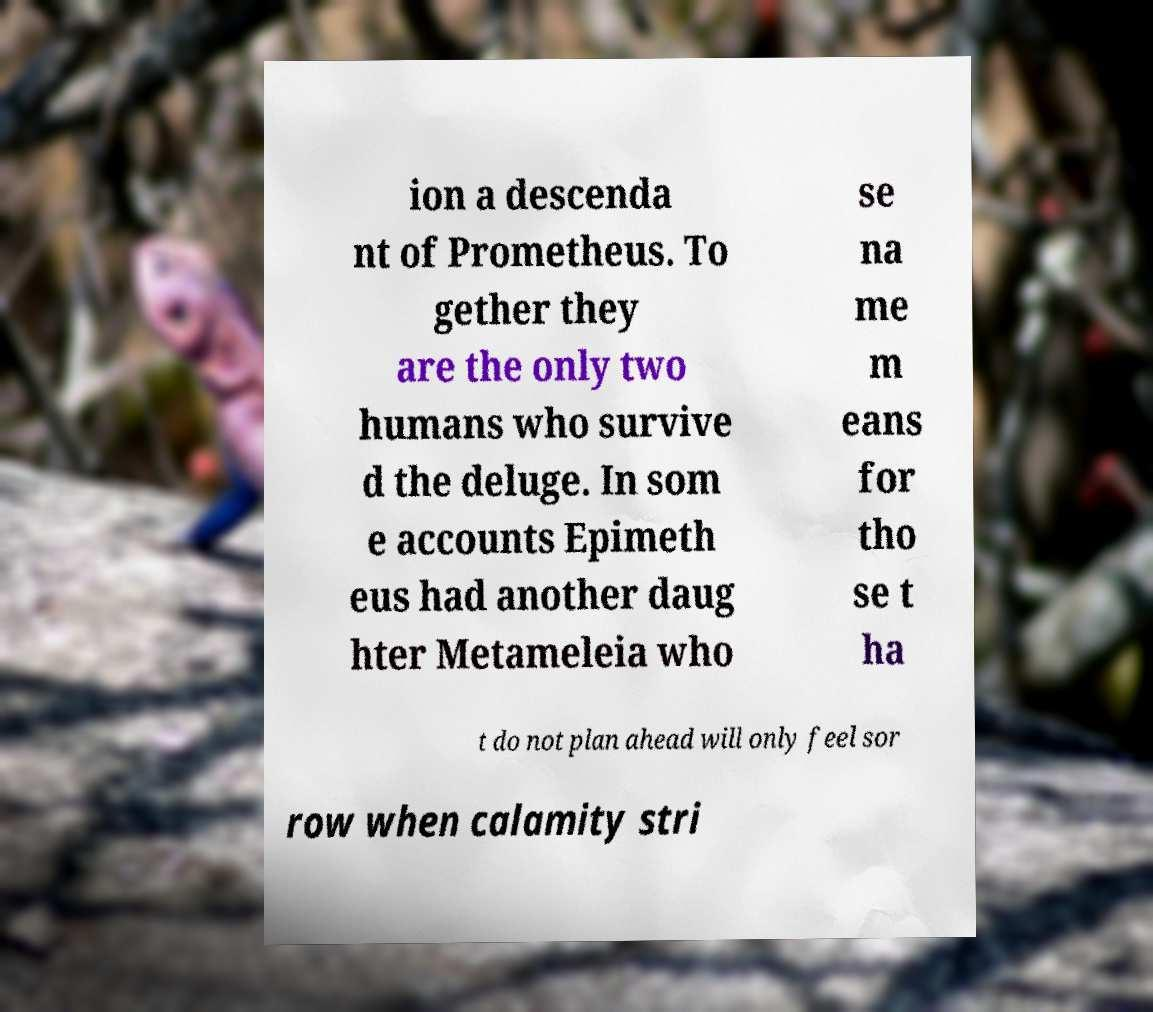For documentation purposes, I need the text within this image transcribed. Could you provide that? ion a descenda nt of Prometheus. To gether they are the only two humans who survive d the deluge. In som e accounts Epimeth eus had another daug hter Metameleia who se na me m eans for tho se t ha t do not plan ahead will only feel sor row when calamity stri 